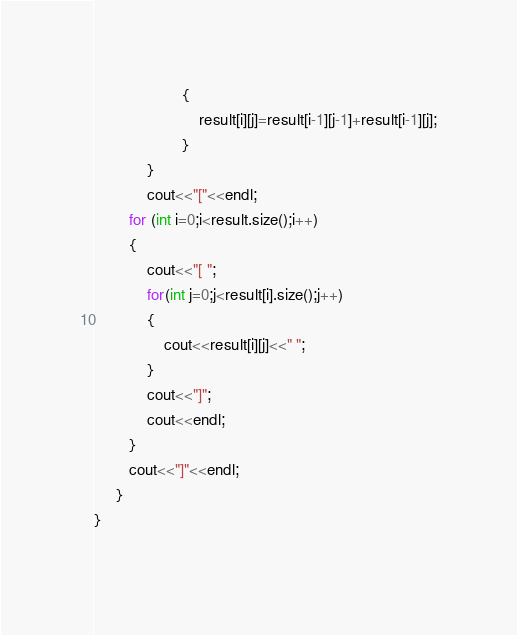Convert code to text. <code><loc_0><loc_0><loc_500><loc_500><_C++_>                    {
                        result[i][j]=result[i-1][j-1]+result[i-1][j];
                    }
            }
            cout<<"["<<endl;
        for (int i=0;i<result.size();i++)
        {
            cout<<"[ ";
            for(int j=0;j<result[i].size();j++)
            {
                cout<<result[i][j]<<" ";
            }
            cout<<"]";
            cout<<endl;
        }
        cout<<"]"<<endl;
     }
}
        
</code> 